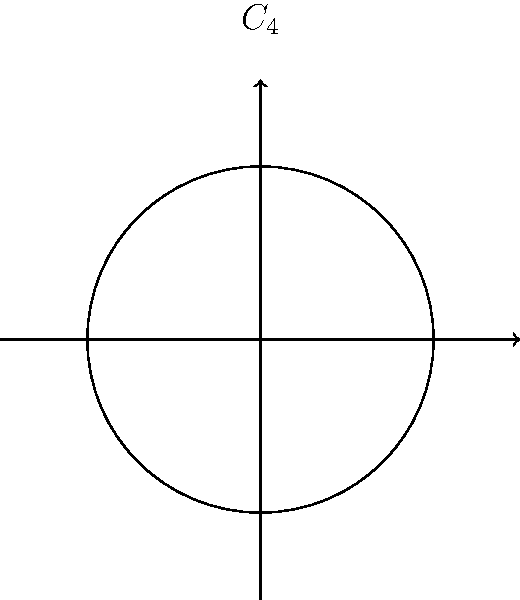During your walk in a Philadelphia park, you notice a circular flower bed arrangement with four identical sections. The landscaper explains that this design has rotational symmetry. If the symmetry group of this arrangement is $C_4$, how many unique rotations (including the identity) preserve the arrangement? Let's approach this step-by-step:

1) The symmetry group $C_4$ refers to the cyclic group of order 4.

2) In the context of rotational symmetry, this means the arrangement looks the same after rotations of certain angles.

3) For $C_4$, the possible rotations are:
   - 0° (identity rotation)
   - 90° (quarter turn)
   - 180° (half turn)
   - 270° (three-quarter turn)

4) Each of these rotations brings the arrangement back to a state indistinguishable from its original position.

5) The next rotation of 360° would be equivalent to the 0° rotation, so it's not counted as a unique rotation.

Therefore, there are 4 unique rotations in the $C_4$ group that preserve the arrangement.
Answer: 4 